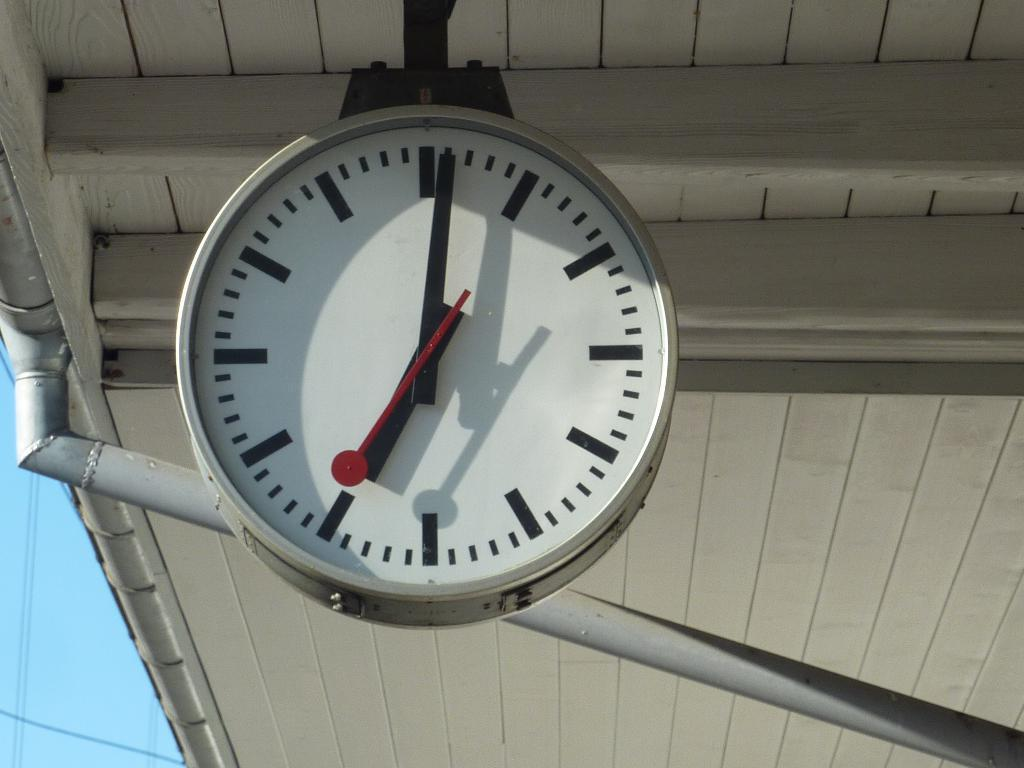What object is hanging on the roof in the image? There is a clock hanging on the roof in the image. Where is the clock located in relation to the image? The clock is in the front of the image. What can be seen behind the clock? There is a pole behind the clock. What is the color of the pole? The pole is white in color. How many teeth can be seen on the clock in the image? There are no teeth visible on the clock in the image, as clocks do not have teeth. 